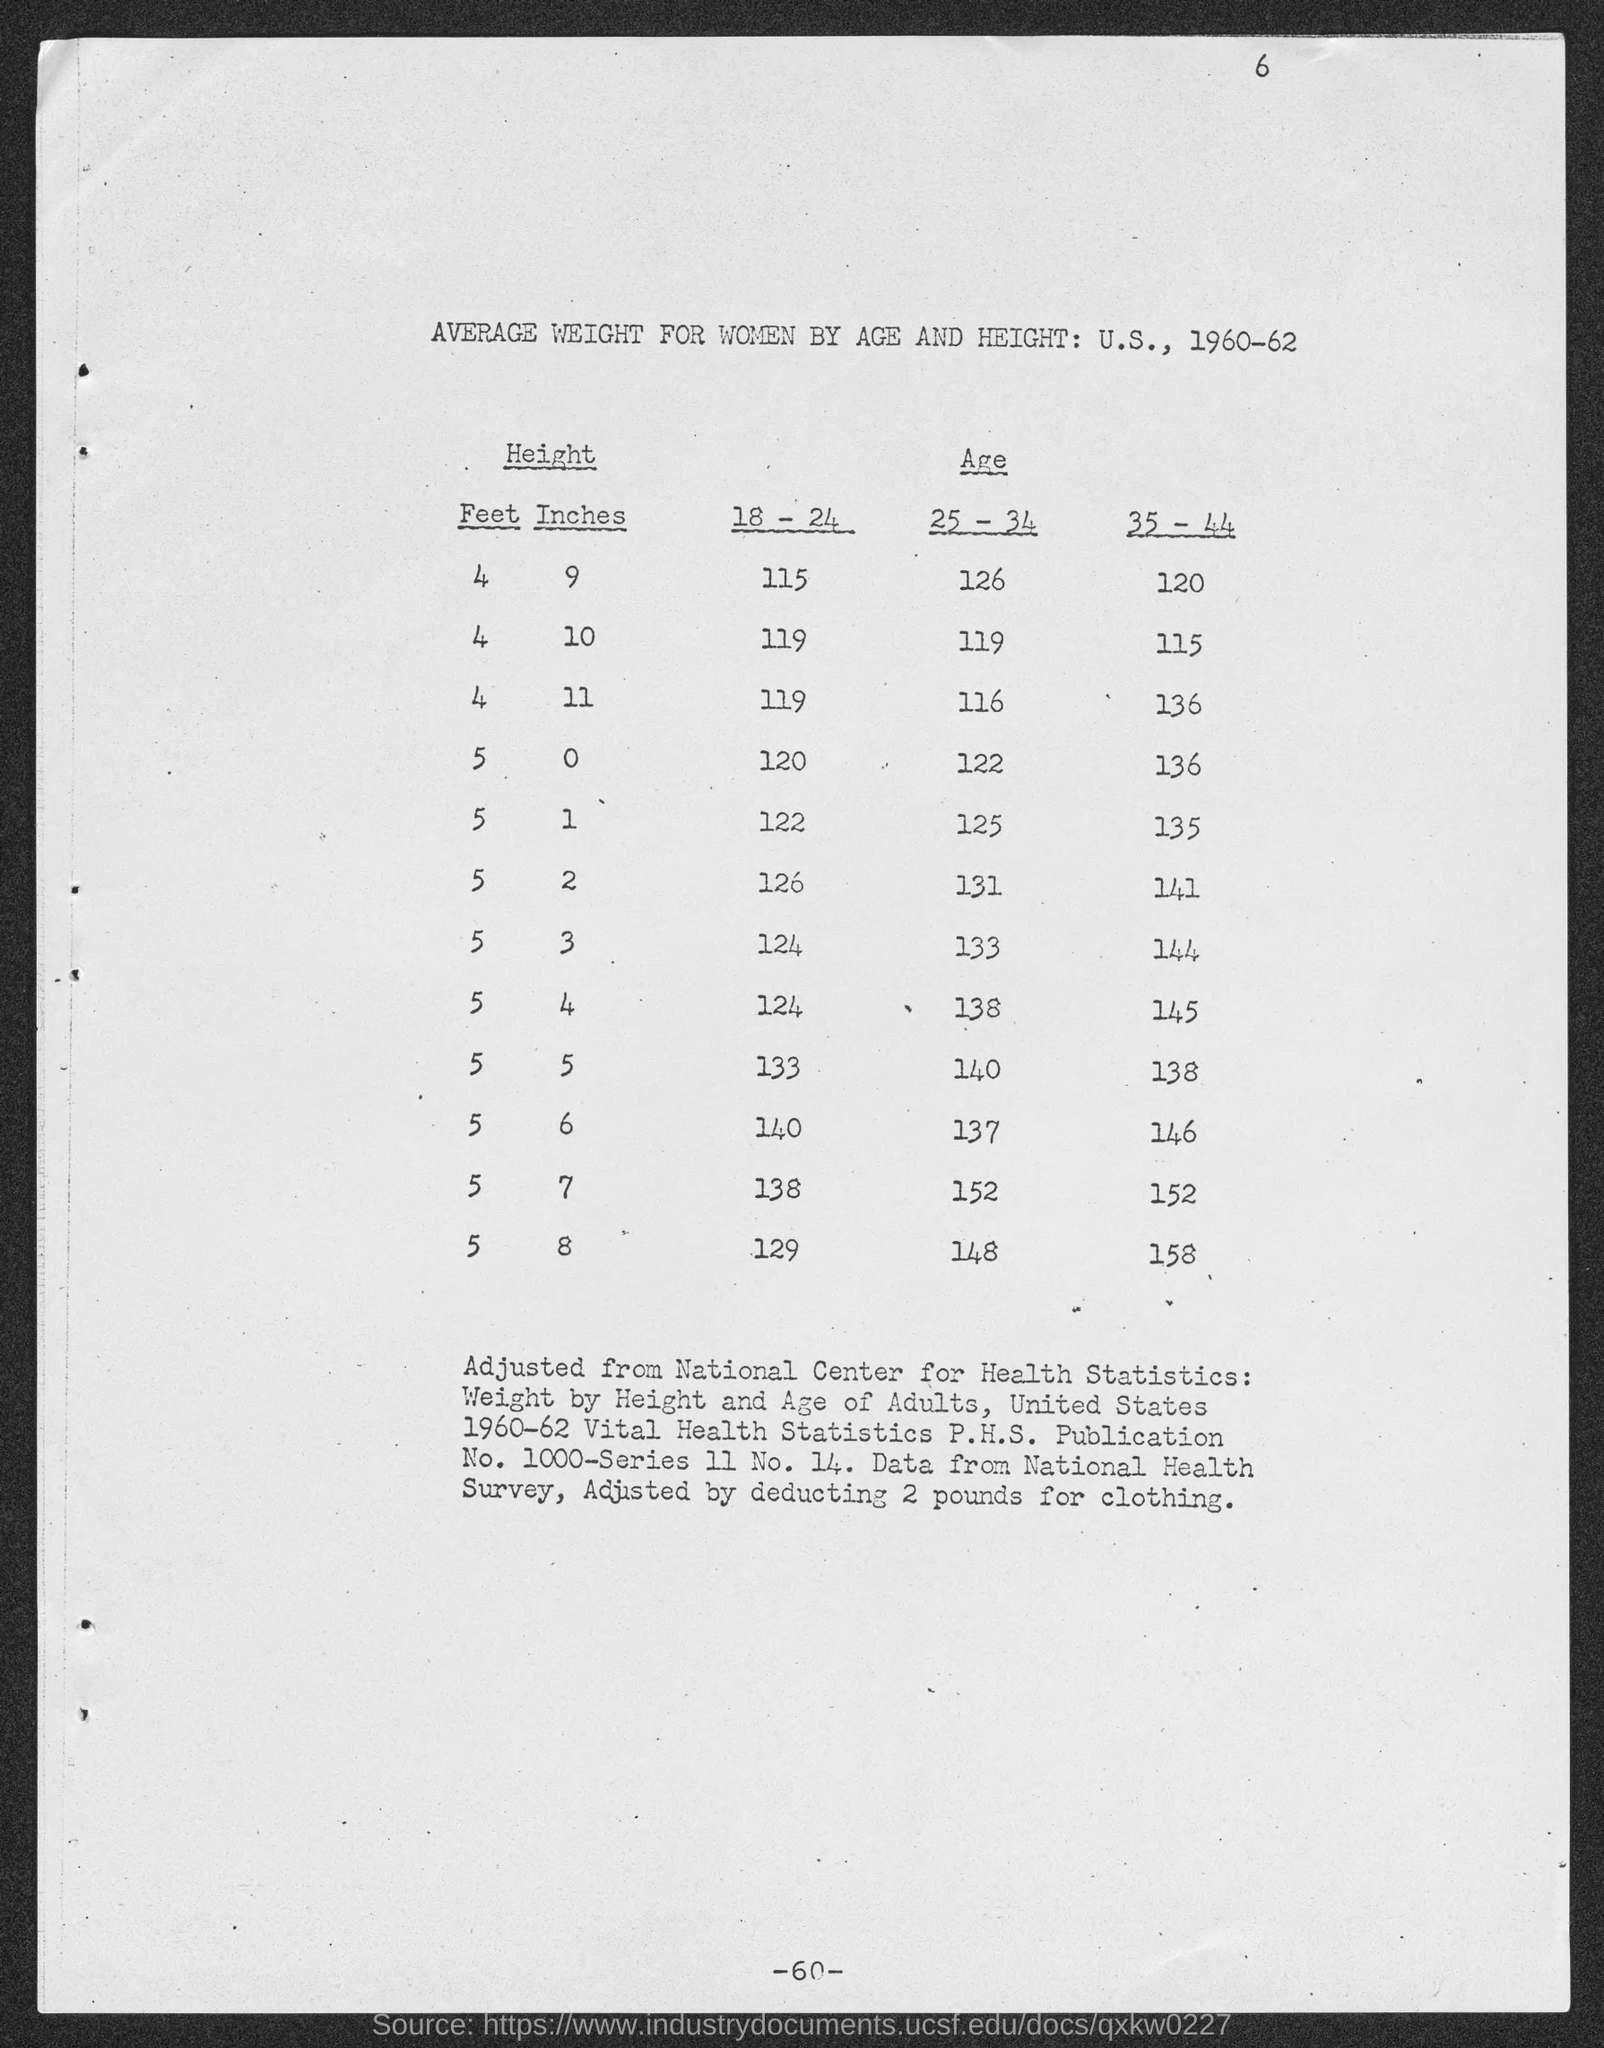How do these historical weight measurements compare to modern standards? Comparison of historical weight measurements to modern standards would reveal several insights. Factors such as overall improvements in health care, nutritional availability, and changes in lifestyle could influence these figures considerably. Modern average weights might be slightly higher due to changes in diet and lower physical activity levels. Additionally, public health aims and metrics of well-being have evolved, affecting how weight measurements are perceived and targeted in health policies. 